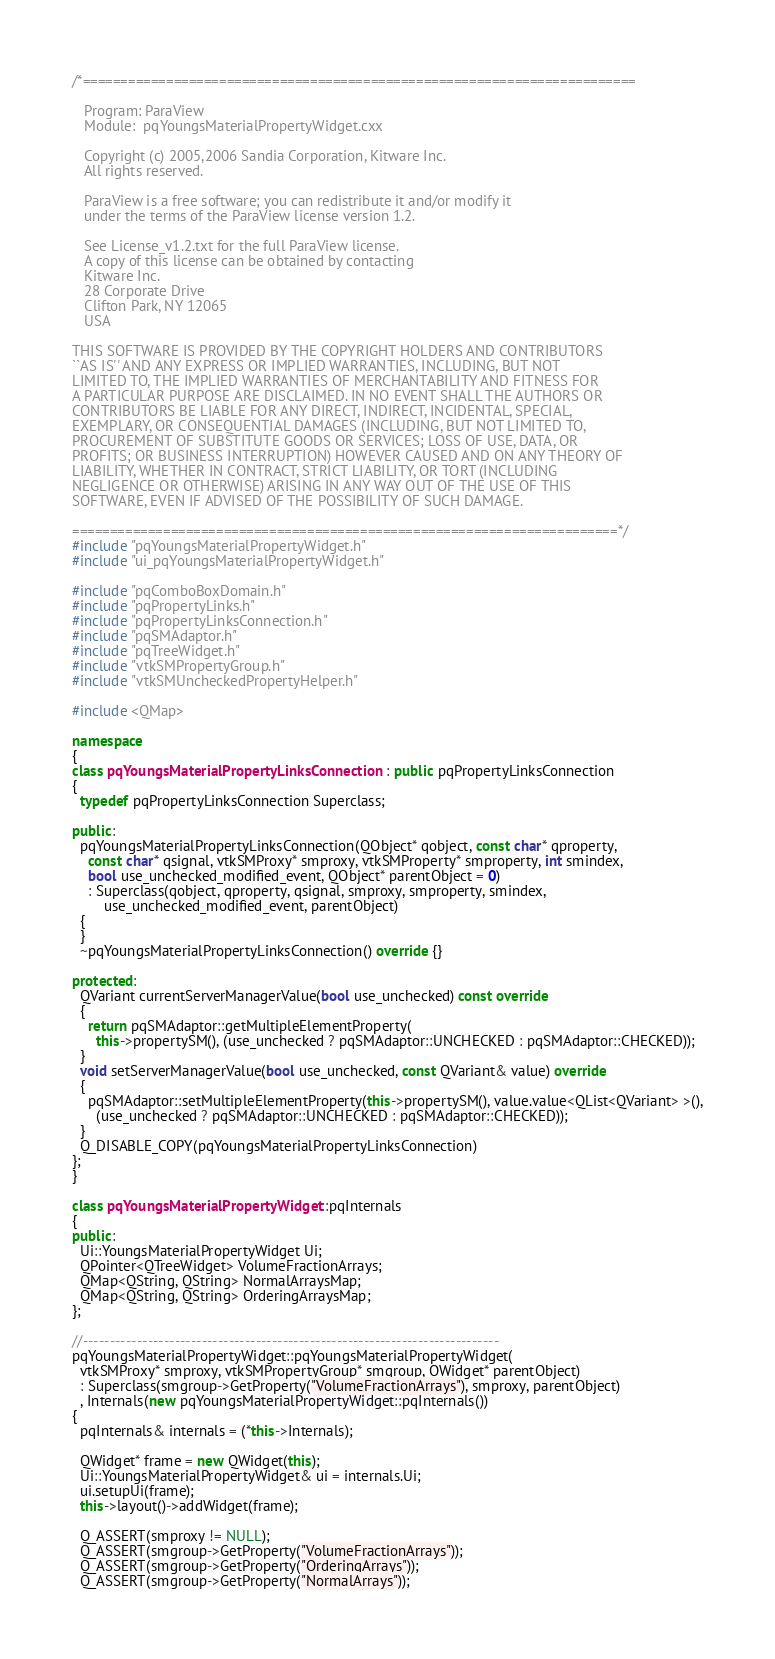Convert code to text. <code><loc_0><loc_0><loc_500><loc_500><_C++_>/*=========================================================================

   Program: ParaView
   Module:  pqYoungsMaterialPropertyWidget.cxx

   Copyright (c) 2005,2006 Sandia Corporation, Kitware Inc.
   All rights reserved.

   ParaView is a free software; you can redistribute it and/or modify it
   under the terms of the ParaView license version 1.2.

   See License_v1.2.txt for the full ParaView license.
   A copy of this license can be obtained by contacting
   Kitware Inc.
   28 Corporate Drive
   Clifton Park, NY 12065
   USA

THIS SOFTWARE IS PROVIDED BY THE COPYRIGHT HOLDERS AND CONTRIBUTORS
``AS IS'' AND ANY EXPRESS OR IMPLIED WARRANTIES, INCLUDING, BUT NOT
LIMITED TO, THE IMPLIED WARRANTIES OF MERCHANTABILITY AND FITNESS FOR
A PARTICULAR PURPOSE ARE DISCLAIMED. IN NO EVENT SHALL THE AUTHORS OR
CONTRIBUTORS BE LIABLE FOR ANY DIRECT, INDIRECT, INCIDENTAL, SPECIAL,
EXEMPLARY, OR CONSEQUENTIAL DAMAGES (INCLUDING, BUT NOT LIMITED TO,
PROCUREMENT OF SUBSTITUTE GOODS OR SERVICES; LOSS OF USE, DATA, OR
PROFITS; OR BUSINESS INTERRUPTION) HOWEVER CAUSED AND ON ANY THEORY OF
LIABILITY, WHETHER IN CONTRACT, STRICT LIABILITY, OR TORT (INCLUDING
NEGLIGENCE OR OTHERWISE) ARISING IN ANY WAY OUT OF THE USE OF THIS
SOFTWARE, EVEN IF ADVISED OF THE POSSIBILITY OF SUCH DAMAGE.

========================================================================*/
#include "pqYoungsMaterialPropertyWidget.h"
#include "ui_pqYoungsMaterialPropertyWidget.h"

#include "pqComboBoxDomain.h"
#include "pqPropertyLinks.h"
#include "pqPropertyLinksConnection.h"
#include "pqSMAdaptor.h"
#include "pqTreeWidget.h"
#include "vtkSMPropertyGroup.h"
#include "vtkSMUncheckedPropertyHelper.h"

#include <QMap>

namespace
{
class pqYoungsMaterialPropertyLinksConnection : public pqPropertyLinksConnection
{
  typedef pqPropertyLinksConnection Superclass;

public:
  pqYoungsMaterialPropertyLinksConnection(QObject* qobject, const char* qproperty,
    const char* qsignal, vtkSMProxy* smproxy, vtkSMProperty* smproperty, int smindex,
    bool use_unchecked_modified_event, QObject* parentObject = 0)
    : Superclass(qobject, qproperty, qsignal, smproxy, smproperty, smindex,
        use_unchecked_modified_event, parentObject)
  {
  }
  ~pqYoungsMaterialPropertyLinksConnection() override {}

protected:
  QVariant currentServerManagerValue(bool use_unchecked) const override
  {
    return pqSMAdaptor::getMultipleElementProperty(
      this->propertySM(), (use_unchecked ? pqSMAdaptor::UNCHECKED : pqSMAdaptor::CHECKED));
  }
  void setServerManagerValue(bool use_unchecked, const QVariant& value) override
  {
    pqSMAdaptor::setMultipleElementProperty(this->propertySM(), value.value<QList<QVariant> >(),
      (use_unchecked ? pqSMAdaptor::UNCHECKED : pqSMAdaptor::CHECKED));
  }
  Q_DISABLE_COPY(pqYoungsMaterialPropertyLinksConnection)
};
}

class pqYoungsMaterialPropertyWidget::pqInternals
{
public:
  Ui::YoungsMaterialPropertyWidget Ui;
  QPointer<QTreeWidget> VolumeFractionArrays;
  QMap<QString, QString> NormalArraysMap;
  QMap<QString, QString> OrderingArraysMap;
};

//-----------------------------------------------------------------------------
pqYoungsMaterialPropertyWidget::pqYoungsMaterialPropertyWidget(
  vtkSMProxy* smproxy, vtkSMPropertyGroup* smgroup, QWidget* parentObject)
  : Superclass(smgroup->GetProperty("VolumeFractionArrays"), smproxy, parentObject)
  , Internals(new pqYoungsMaterialPropertyWidget::pqInternals())
{
  pqInternals& internals = (*this->Internals);

  QWidget* frame = new QWidget(this);
  Ui::YoungsMaterialPropertyWidget& ui = internals.Ui;
  ui.setupUi(frame);
  this->layout()->addWidget(frame);

  Q_ASSERT(smproxy != NULL);
  Q_ASSERT(smgroup->GetProperty("VolumeFractionArrays"));
  Q_ASSERT(smgroup->GetProperty("OrderingArrays"));
  Q_ASSERT(smgroup->GetProperty("NormalArrays"));
</code> 